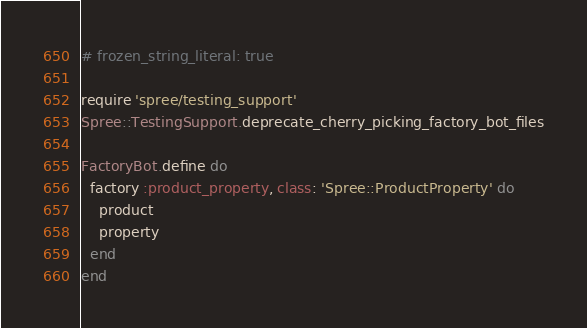Convert code to text. <code><loc_0><loc_0><loc_500><loc_500><_Ruby_># frozen_string_literal: true

require 'spree/testing_support'
Spree::TestingSupport.deprecate_cherry_picking_factory_bot_files

FactoryBot.define do
  factory :product_property, class: 'Spree::ProductProperty' do
    product
    property
  end
end
</code> 